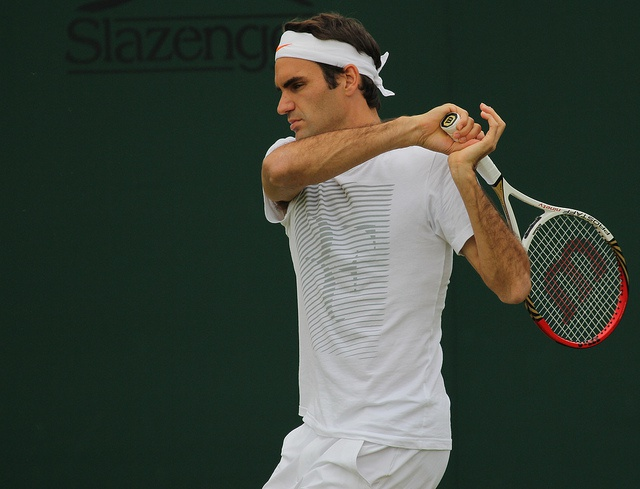Describe the objects in this image and their specific colors. I can see people in black, darkgray, lightgray, and brown tones and tennis racket in black, darkgray, gray, and maroon tones in this image. 